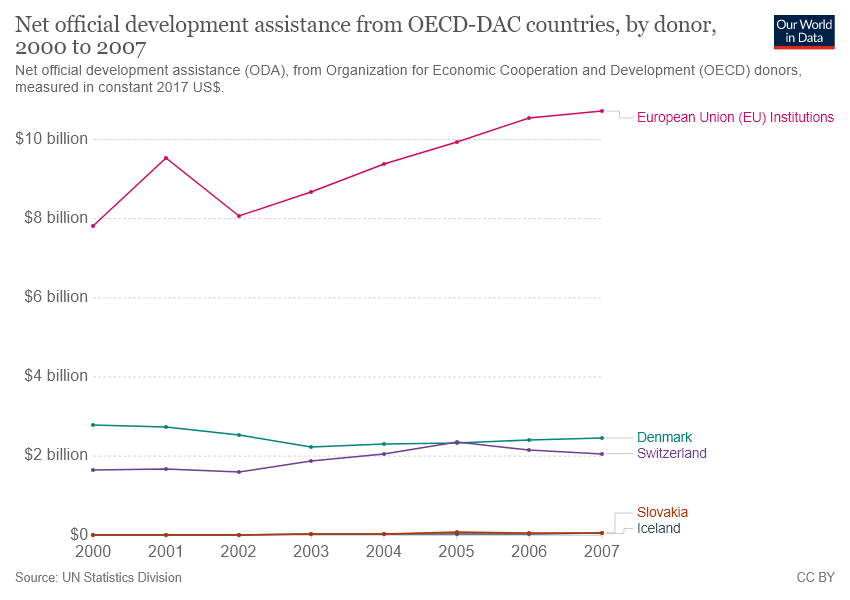Can you explain the trend in ODA contributions by European Union (EU) Institutions from 2000 to 2007? The line graph shows a generally increasing trend in ODA contributions by European Union (EU) Institutions from 2000 to 2007, with a notable dip in 2002 where the contributions momentarily decreased. Overall, the trend suggests that the EU Institutions have ramped up their development assistance efforts over this period, peaking at just over $8 billion in 2006 before a slight decrease in 2007. 